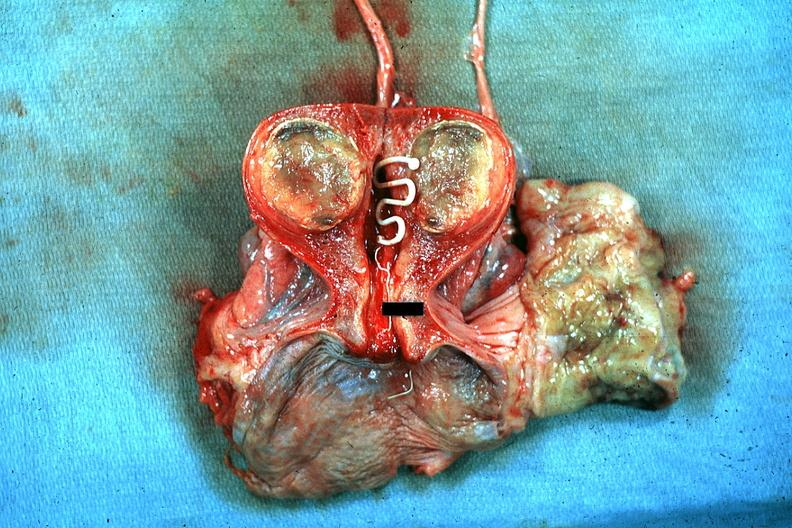what is present?
Answer the question using a single word or phrase. Female reproductive 